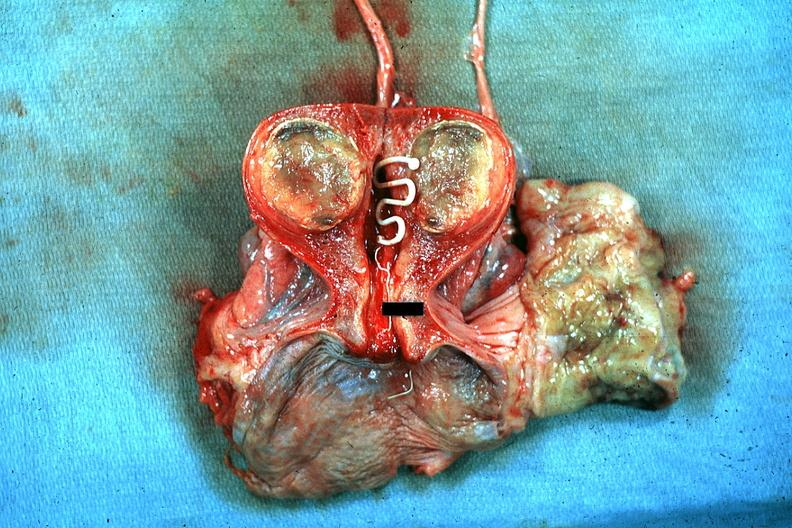what is present?
Answer the question using a single word or phrase. Female reproductive 